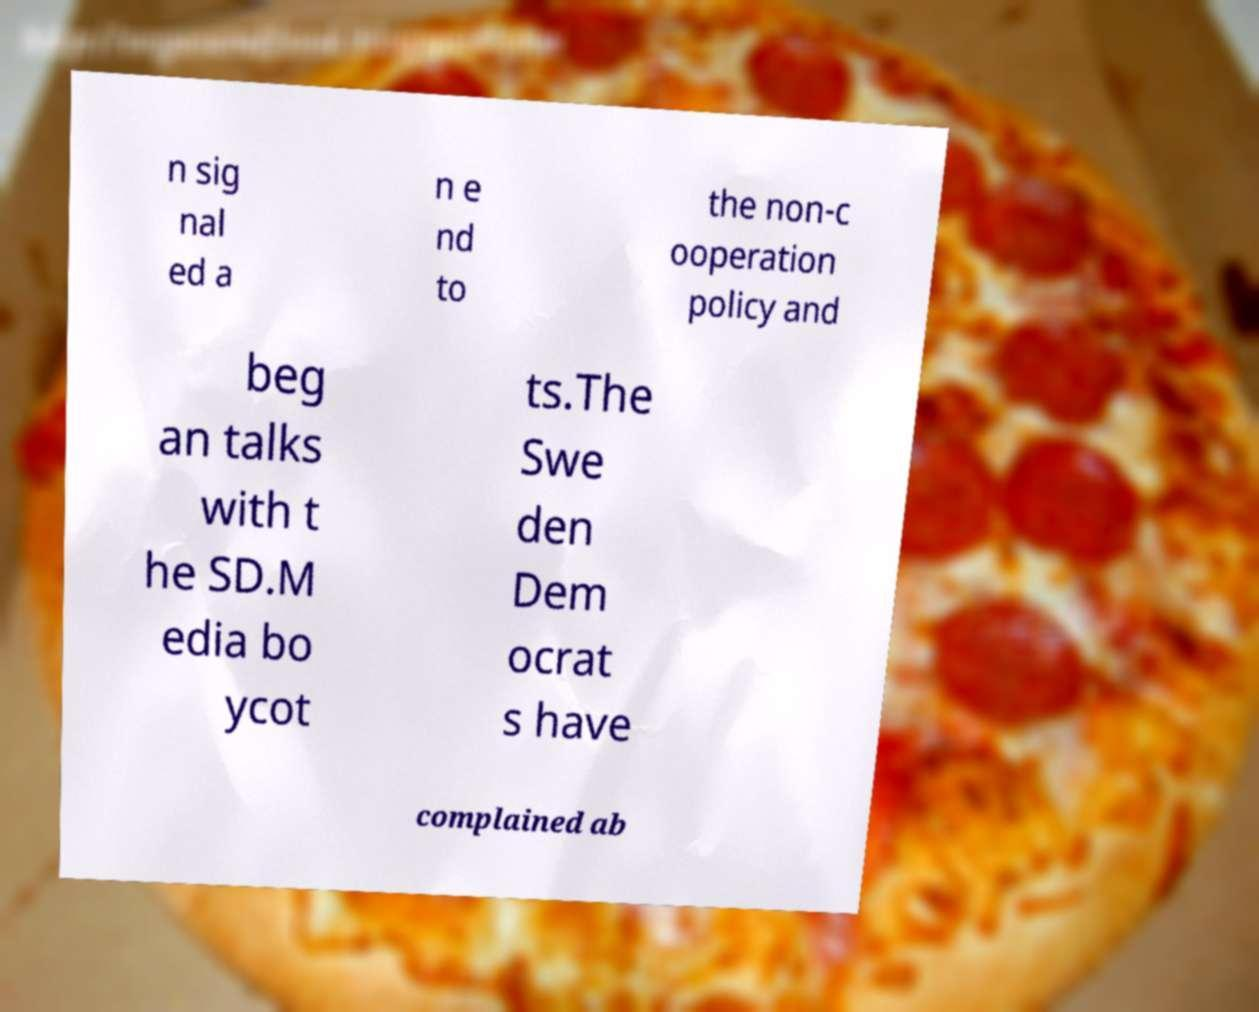Could you extract and type out the text from this image? n sig nal ed a n e nd to the non-c ooperation policy and beg an talks with t he SD.M edia bo ycot ts.The Swe den Dem ocrat s have complained ab 